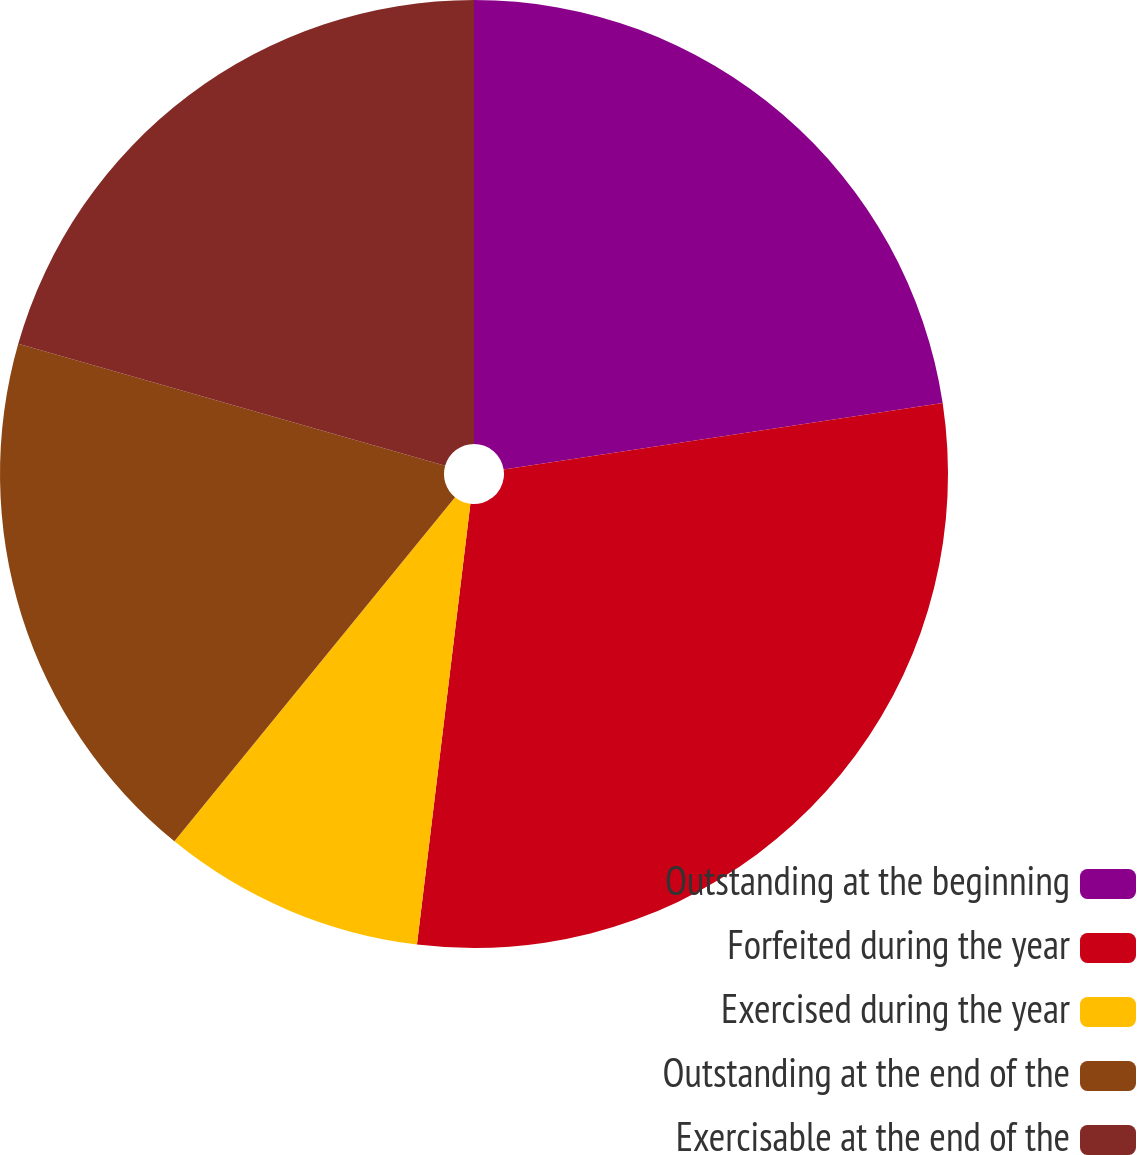Convert chart to OTSL. <chart><loc_0><loc_0><loc_500><loc_500><pie_chart><fcel>Outstanding at the beginning<fcel>Forfeited during the year<fcel>Exercised during the year<fcel>Outstanding at the end of the<fcel>Exercisable at the end of the<nl><fcel>22.61%<fcel>29.31%<fcel>8.97%<fcel>18.54%<fcel>20.57%<nl></chart> 